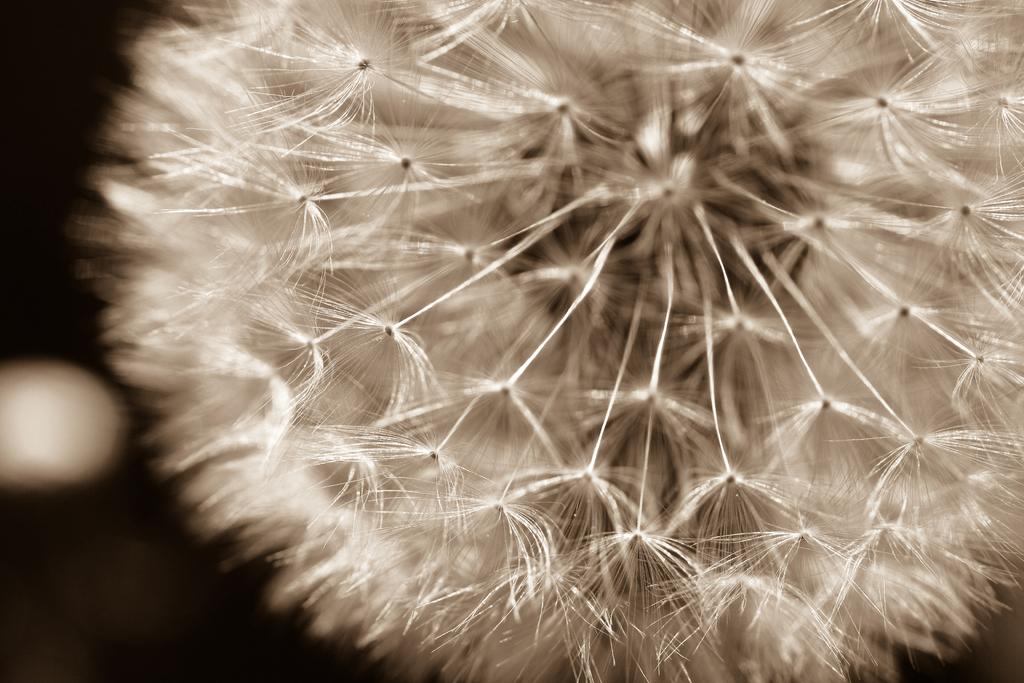What type of flower is in the image? There is a white color flower in the image. What is the color of the flower? The flower is white. What can be seen in the background of the image? The background of the image is dark. What type of cough medicine is visible in the image? There is no cough medicine present in the image. What type of juice is being poured from a container in the image? There is no container or juice present in the image. 